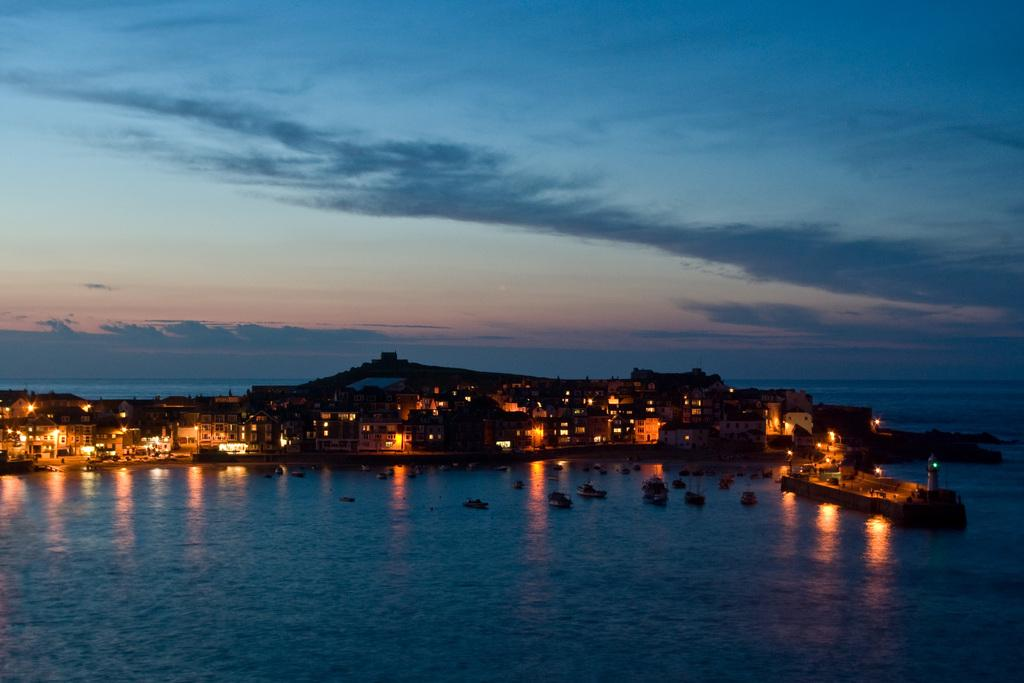What can be seen in the sky in the image? The sky is visible in the image. What body of water is present in the image? There is a lake in the image. What is on the lake in the image? A boat is present on the lake. What structure is located in front of the lake in the image? There is a building in front of the lake. What is illuminated in the middle of the image? Lights are visible in the middle of the image. How many goose feet can be seen in the image? There are no goose feet present in the image. What type of sorting method is used for the lights in the image? There is no sorting method mentioned or visible for the lights in the image. 